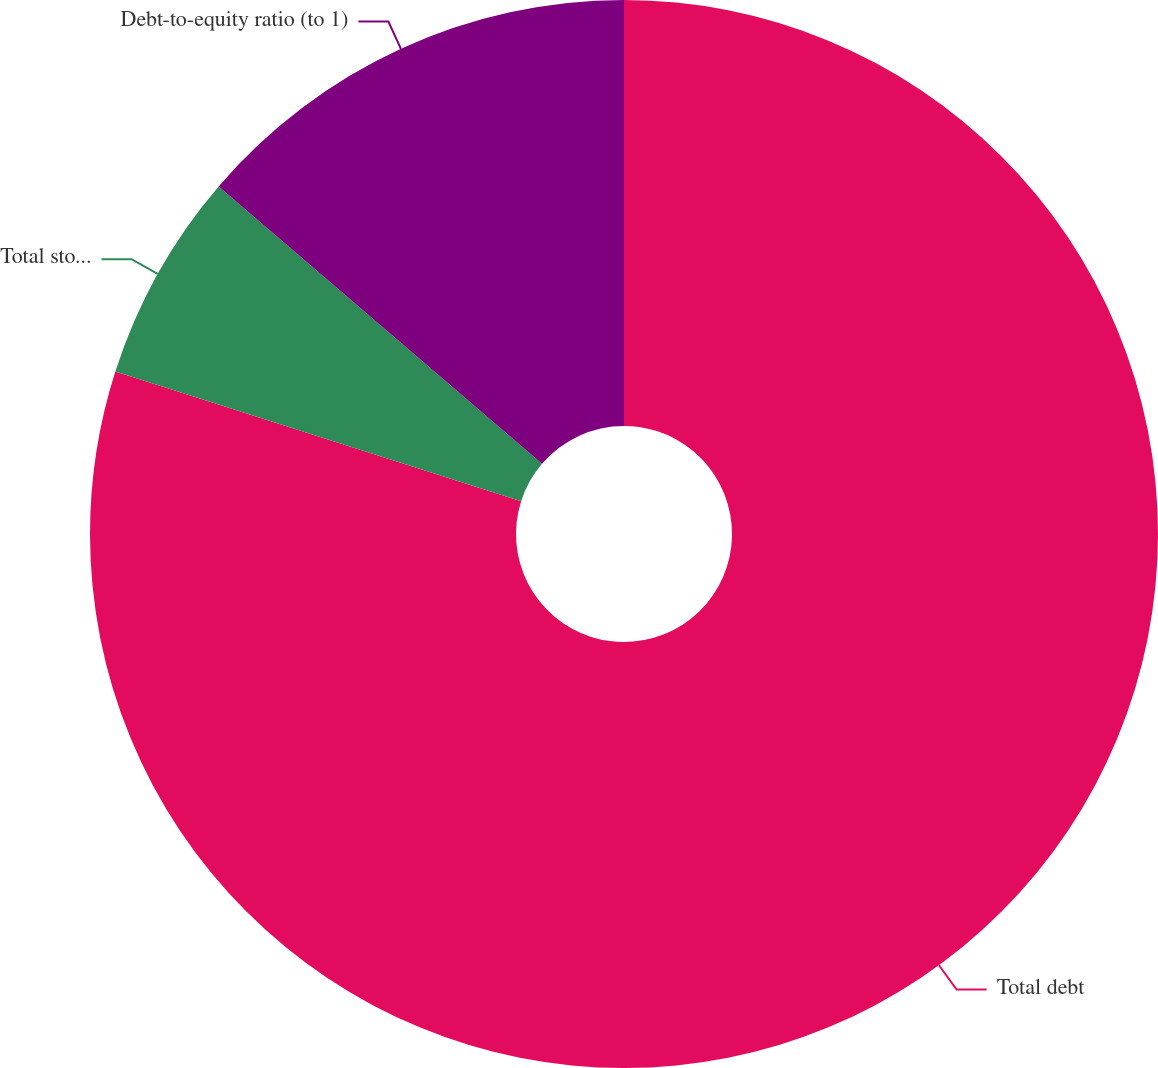Convert chart. <chart><loc_0><loc_0><loc_500><loc_500><pie_chart><fcel>Total debt<fcel>Total stockholder's equity<fcel>Debt-to-equity ratio (to 1)<nl><fcel>79.93%<fcel>6.36%<fcel>13.72%<nl></chart> 